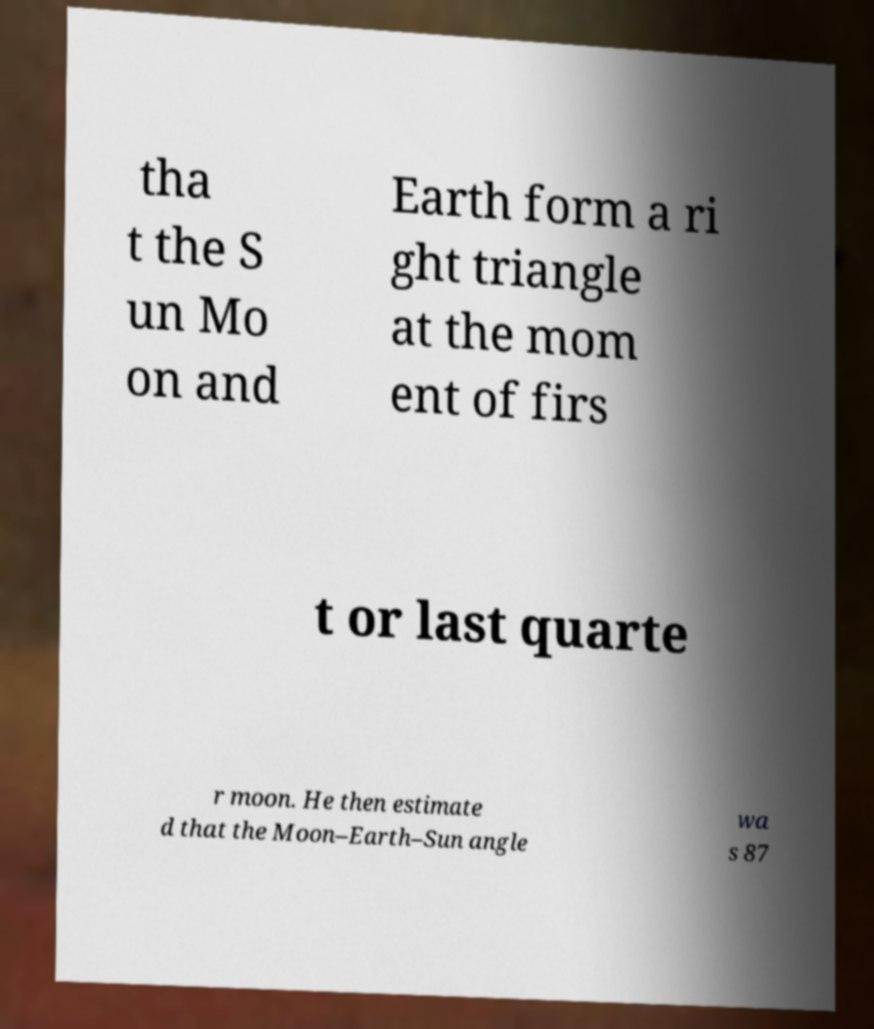Please read and relay the text visible in this image. What does it say? tha t the S un Mo on and Earth form a ri ght triangle at the mom ent of firs t or last quarte r moon. He then estimate d that the Moon–Earth–Sun angle wa s 87 